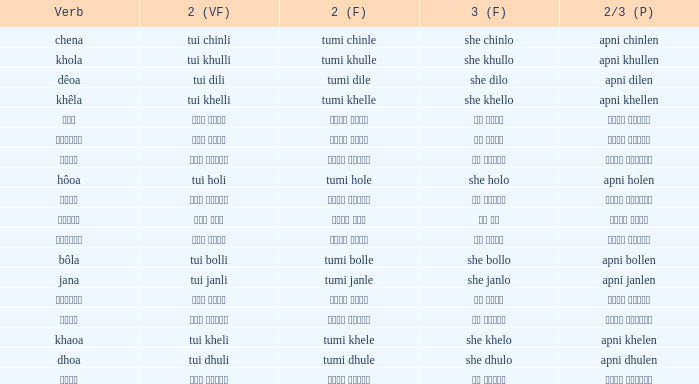What is the 2nd verb for Khola? Tumi khulle. Would you mind parsing the complete table? {'header': ['Verb', '2 (VF)', '2 (F)', '3 (F)', '2/3 (P)'], 'rows': [['chena', 'tui chinli', 'tumi chinle', 'she chinlo', 'apni chinlen'], ['khola', 'tui khulli', 'tumi khulle', 'she khullo', 'apni khullen'], ['dêoa', 'tui dili', 'tumi dile', 'she dilo', 'apni dilen'], ['khêla', 'tui khelli', 'tumi khelle', 'she khello', 'apni khellen'], ['বলা', 'তুই বললি', 'তুমি বললে', 'সে বললো', 'আপনি বললেন'], ['খাওয়া', 'তুই খেলি', 'তুমি খেলে', 'সে খেলো', 'আপনি খেলেন'], ['জানা', 'তুই জানলি', 'তুমি জানলে', 'সে জানলে', 'আপনি জানলেন'], ['hôoa', 'tui holi', 'tumi hole', 'she holo', 'apni holen'], ['খেলে', 'তুই খেললি', 'তুমি খেললে', 'সে খেললো', 'আপনি খেললেন'], ['হওয়া', 'তুই হলি', 'তুমি হলে', 'সে হল', 'আপনি হলেন'], ['ধোওয়া', 'তুই ধুলি', 'তুমি ধুলে', 'সে ধুলো', 'আপনি ধুলেন'], ['bôla', 'tui bolli', 'tumi bolle', 'she bollo', 'apni bollen'], ['jana', 'tui janli', 'tumi janle', 'she janlo', 'apni janlen'], ['দেওয়া', 'তুই দিলি', 'তুমি দিলে', 'সে দিলো', 'আপনি দিলেন'], ['চেনা', 'তুই চিনলি', 'তুমি চিনলে', 'সে চিনলো', 'আপনি চিনলেন'], ['khaoa', 'tui kheli', 'tumi khele', 'she khelo', 'apni khelen'], ['dhoa', 'tui dhuli', 'tumi dhule', 'she dhulo', 'apni dhulen'], ['খোলা', 'তুই খুললি', 'তুমি খুললে', 'সে খুললো', 'আপনি খুললেন']]} 